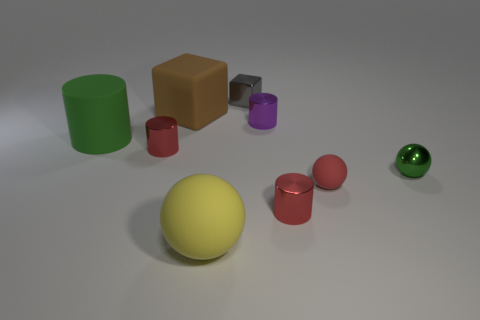What number of tiny red things are to the right of the brown matte object left of the tiny rubber thing?
Your answer should be very brief. 2. There is a tiny object that is to the right of the small purple shiny object and left of the red sphere; what material is it?
Make the answer very short. Metal. Is the shape of the green thing right of the gray shiny block the same as  the large yellow thing?
Your answer should be compact. Yes. Are there fewer gray rubber spheres than tiny blocks?
Offer a terse response. Yes. How many big cubes have the same color as the tiny rubber ball?
Provide a succinct answer. 0. There is a thing that is the same color as the matte cylinder; what is it made of?
Your answer should be compact. Metal. There is a small matte object; does it have the same color as the small metallic object in front of the red matte ball?
Give a very brief answer. Yes. Are there more green metallic objects than large cyan rubber cylinders?
Give a very brief answer. Yes. There is a shiny object that is the same shape as the small matte object; what is its size?
Offer a very short reply. Small. Are the red sphere and the green thing that is on the left side of the yellow sphere made of the same material?
Keep it short and to the point. Yes. 